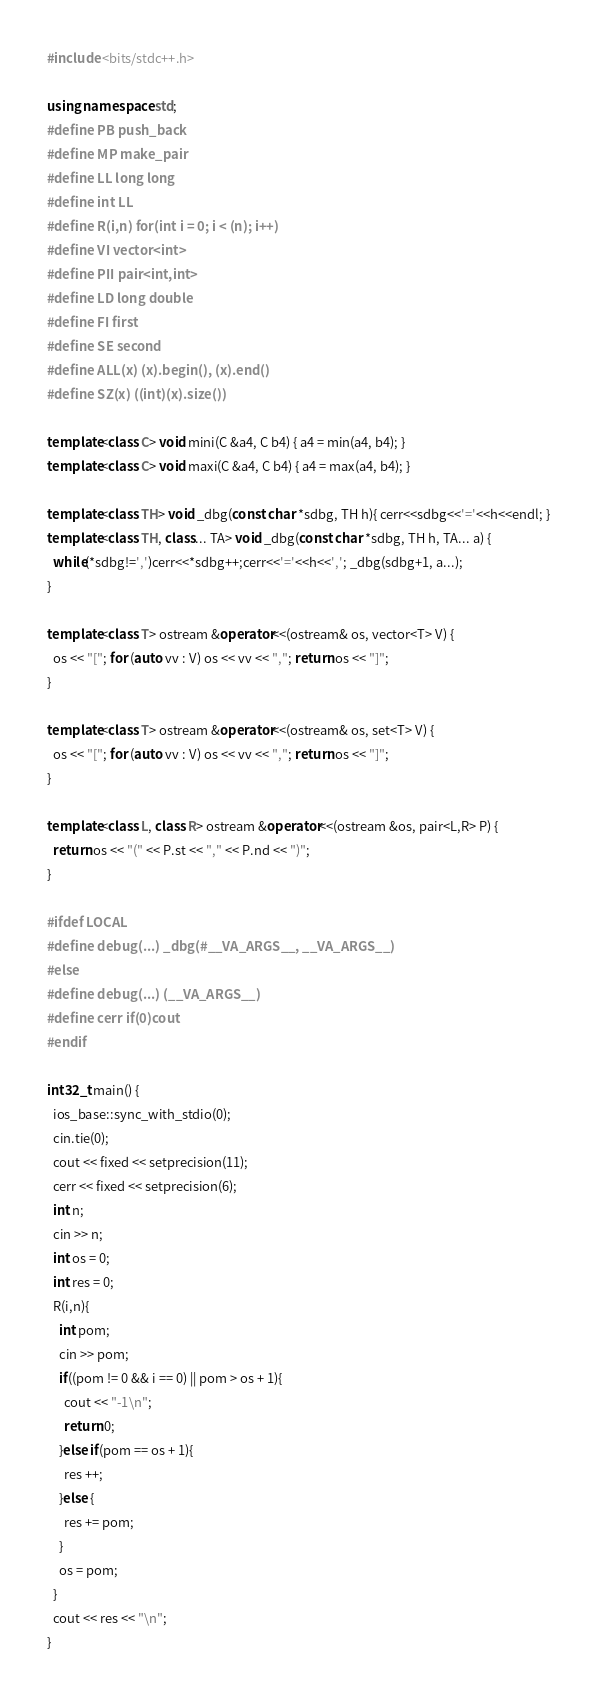<code> <loc_0><loc_0><loc_500><loc_500><_C++_>#include <bits/stdc++.h>

using namespace std;
#define PB push_back
#define MP make_pair
#define LL long long
#define int LL
#define R(i,n) for(int i = 0; i < (n); i++)
#define VI vector<int>
#define PII pair<int,int>
#define LD long double
#define FI first
#define SE second
#define ALL(x) (x).begin(), (x).end()
#define SZ(x) ((int)(x).size())

template<class C> void mini(C &a4, C b4) { a4 = min(a4, b4); }
template<class C> void maxi(C &a4, C b4) { a4 = max(a4, b4); }

template<class TH> void _dbg(const char *sdbg, TH h){ cerr<<sdbg<<'='<<h<<endl; }
template<class TH, class... TA> void _dbg(const char *sdbg, TH h, TA... a) {
  while(*sdbg!=',')cerr<<*sdbg++;cerr<<'='<<h<<','; _dbg(sdbg+1, a...);
}

template<class T> ostream &operator<<(ostream& os, vector<T> V) {
  os << "["; for (auto vv : V) os << vv << ","; return os << "]";
}

template<class T> ostream &operator<<(ostream& os, set<T> V) {
  os << "["; for (auto vv : V) os << vv << ","; return os << "]";
}

template<class L, class R> ostream &operator<<(ostream &os, pair<L,R> P) {
  return os << "(" << P.st << "," << P.nd << ")";
}

#ifdef LOCAL
#define debug(...) _dbg(#__VA_ARGS__, __VA_ARGS__)
#else
#define debug(...) (__VA_ARGS__)
#define cerr if(0)cout
#endif

int32_t main() {
  ios_base::sync_with_stdio(0);
  cin.tie(0);
  cout << fixed << setprecision(11);
  cerr << fixed << setprecision(6);
  int n;
  cin >> n;
  int os = 0;
  int res = 0;
  R(i,n){
    int pom;
    cin >> pom;
    if((pom != 0 && i == 0) || pom > os + 1){
      cout << "-1\n";
      return 0;
    }else if(pom == os + 1){
      res ++;
    }else {
      res += pom;
    }
    os = pom;
  }
  cout << res << "\n";
}


</code> 